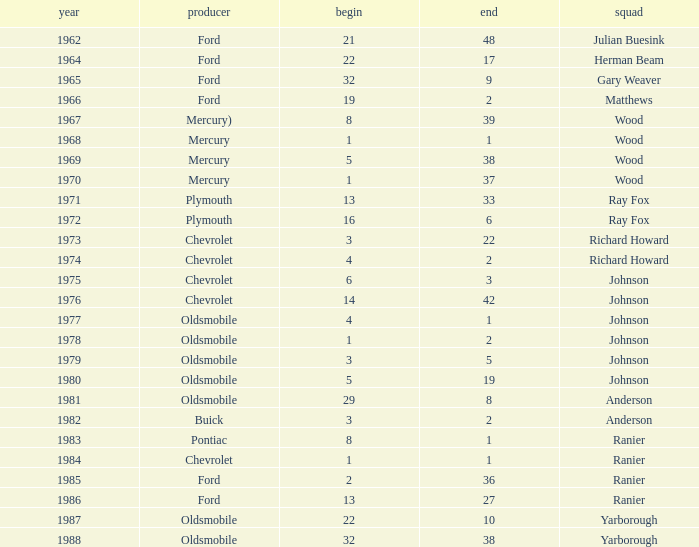Who was the maufacturer of the vehicle during the race where Cale Yarborough started at 19 and finished earlier than 42? Ford. 